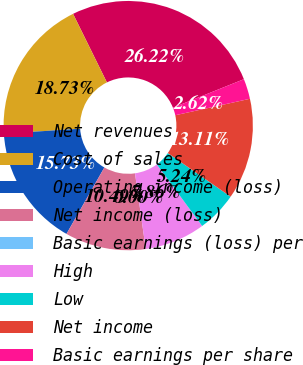<chart> <loc_0><loc_0><loc_500><loc_500><pie_chart><fcel>Net revenues<fcel>Cost of sales<fcel>Operating income (loss)<fcel>Net income (loss)<fcel>Basic earnings (loss) per<fcel>High<fcel>Low<fcel>Net income<fcel>Basic earnings per share<nl><fcel>26.22%<fcel>18.73%<fcel>15.73%<fcel>10.49%<fcel>0.0%<fcel>7.86%<fcel>5.24%<fcel>13.11%<fcel>2.62%<nl></chart> 